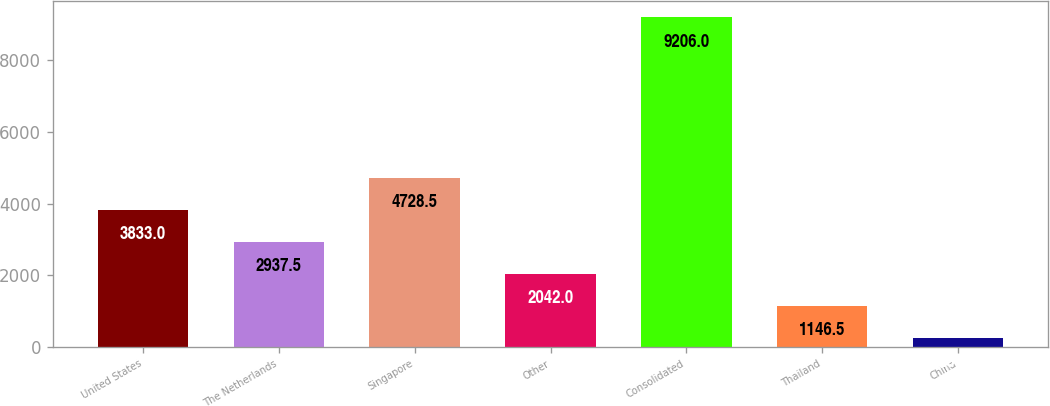<chart> <loc_0><loc_0><loc_500><loc_500><bar_chart><fcel>United States<fcel>The Netherlands<fcel>Singapore<fcel>Other<fcel>Consolidated<fcel>Thailand<fcel>China<nl><fcel>3833<fcel>2937.5<fcel>4728.5<fcel>2042<fcel>9206<fcel>1146.5<fcel>251<nl></chart> 